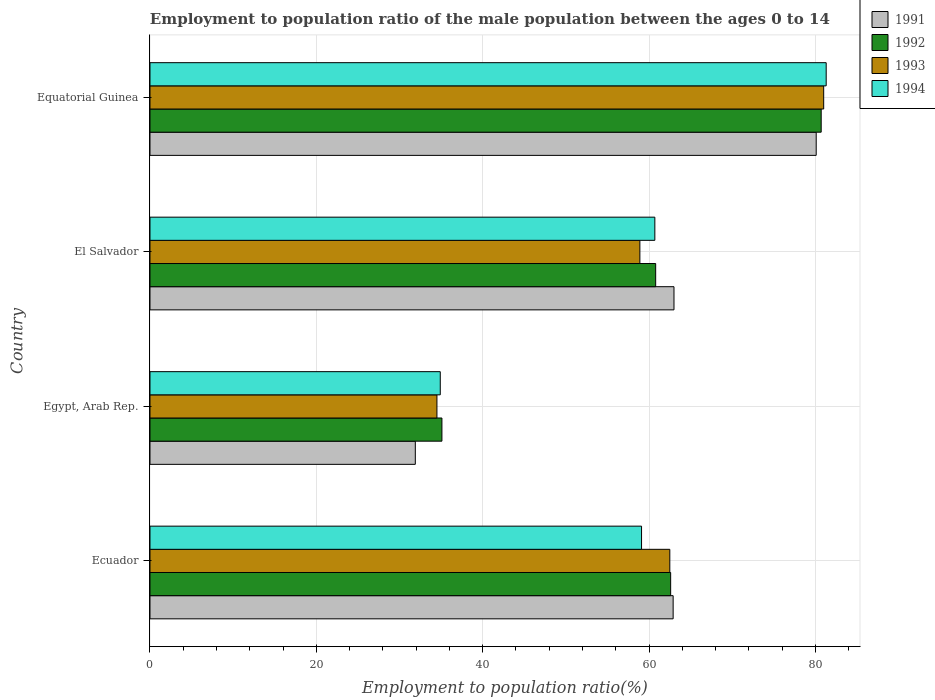How many groups of bars are there?
Your answer should be compact. 4. Are the number of bars on each tick of the Y-axis equal?
Provide a short and direct response. Yes. How many bars are there on the 2nd tick from the bottom?
Your answer should be very brief. 4. What is the label of the 4th group of bars from the top?
Provide a succinct answer. Ecuador. In how many cases, is the number of bars for a given country not equal to the number of legend labels?
Keep it short and to the point. 0. What is the employment to population ratio in 1992 in Equatorial Guinea?
Offer a terse response. 80.7. Across all countries, what is the minimum employment to population ratio in 1991?
Keep it short and to the point. 31.9. In which country was the employment to population ratio in 1993 maximum?
Your answer should be compact. Equatorial Guinea. In which country was the employment to population ratio in 1991 minimum?
Your answer should be very brief. Egypt, Arab Rep. What is the total employment to population ratio in 1992 in the graph?
Your answer should be very brief. 239.2. What is the difference between the employment to population ratio in 1992 in Ecuador and that in Egypt, Arab Rep.?
Provide a short and direct response. 27.5. What is the difference between the employment to population ratio in 1991 in Egypt, Arab Rep. and the employment to population ratio in 1992 in Ecuador?
Your response must be concise. -30.7. What is the average employment to population ratio in 1992 per country?
Provide a short and direct response. 59.8. What is the difference between the employment to population ratio in 1994 and employment to population ratio in 1992 in Egypt, Arab Rep.?
Keep it short and to the point. -0.2. In how many countries, is the employment to population ratio in 1993 greater than 68 %?
Keep it short and to the point. 1. What is the ratio of the employment to population ratio in 1993 in Egypt, Arab Rep. to that in Equatorial Guinea?
Ensure brevity in your answer.  0.43. What is the difference between the highest and the second highest employment to population ratio in 1992?
Your answer should be very brief. 18.1. What is the difference between the highest and the lowest employment to population ratio in 1993?
Your response must be concise. 46.5. Is the sum of the employment to population ratio in 1994 in Ecuador and El Salvador greater than the maximum employment to population ratio in 1991 across all countries?
Your answer should be compact. Yes. What does the 4th bar from the top in El Salvador represents?
Your answer should be compact. 1991. What does the 2nd bar from the bottom in Ecuador represents?
Your answer should be very brief. 1992. Are all the bars in the graph horizontal?
Give a very brief answer. Yes. Does the graph contain any zero values?
Offer a terse response. No. Where does the legend appear in the graph?
Your answer should be compact. Top right. How many legend labels are there?
Provide a short and direct response. 4. What is the title of the graph?
Provide a succinct answer. Employment to population ratio of the male population between the ages 0 to 14. What is the label or title of the X-axis?
Provide a succinct answer. Employment to population ratio(%). What is the Employment to population ratio(%) in 1991 in Ecuador?
Offer a terse response. 62.9. What is the Employment to population ratio(%) in 1992 in Ecuador?
Your answer should be compact. 62.6. What is the Employment to population ratio(%) in 1993 in Ecuador?
Offer a very short reply. 62.5. What is the Employment to population ratio(%) in 1994 in Ecuador?
Ensure brevity in your answer.  59.1. What is the Employment to population ratio(%) in 1991 in Egypt, Arab Rep.?
Your answer should be compact. 31.9. What is the Employment to population ratio(%) in 1992 in Egypt, Arab Rep.?
Provide a succinct answer. 35.1. What is the Employment to population ratio(%) in 1993 in Egypt, Arab Rep.?
Offer a very short reply. 34.5. What is the Employment to population ratio(%) in 1994 in Egypt, Arab Rep.?
Offer a very short reply. 34.9. What is the Employment to population ratio(%) in 1991 in El Salvador?
Provide a succinct answer. 63. What is the Employment to population ratio(%) of 1992 in El Salvador?
Your answer should be very brief. 60.8. What is the Employment to population ratio(%) of 1993 in El Salvador?
Provide a short and direct response. 58.9. What is the Employment to population ratio(%) of 1994 in El Salvador?
Make the answer very short. 60.7. What is the Employment to population ratio(%) in 1991 in Equatorial Guinea?
Offer a terse response. 80.1. What is the Employment to population ratio(%) of 1992 in Equatorial Guinea?
Your response must be concise. 80.7. What is the Employment to population ratio(%) of 1993 in Equatorial Guinea?
Provide a short and direct response. 81. What is the Employment to population ratio(%) in 1994 in Equatorial Guinea?
Your answer should be very brief. 81.3. Across all countries, what is the maximum Employment to population ratio(%) in 1991?
Provide a short and direct response. 80.1. Across all countries, what is the maximum Employment to population ratio(%) in 1992?
Offer a terse response. 80.7. Across all countries, what is the maximum Employment to population ratio(%) of 1993?
Your answer should be very brief. 81. Across all countries, what is the maximum Employment to population ratio(%) of 1994?
Provide a short and direct response. 81.3. Across all countries, what is the minimum Employment to population ratio(%) of 1991?
Your response must be concise. 31.9. Across all countries, what is the minimum Employment to population ratio(%) of 1992?
Make the answer very short. 35.1. Across all countries, what is the minimum Employment to population ratio(%) in 1993?
Your answer should be compact. 34.5. Across all countries, what is the minimum Employment to population ratio(%) of 1994?
Give a very brief answer. 34.9. What is the total Employment to population ratio(%) of 1991 in the graph?
Your answer should be very brief. 237.9. What is the total Employment to population ratio(%) of 1992 in the graph?
Keep it short and to the point. 239.2. What is the total Employment to population ratio(%) in 1993 in the graph?
Your answer should be very brief. 236.9. What is the total Employment to population ratio(%) in 1994 in the graph?
Offer a very short reply. 236. What is the difference between the Employment to population ratio(%) in 1992 in Ecuador and that in Egypt, Arab Rep.?
Offer a very short reply. 27.5. What is the difference between the Employment to population ratio(%) in 1993 in Ecuador and that in Egypt, Arab Rep.?
Make the answer very short. 28. What is the difference between the Employment to population ratio(%) in 1994 in Ecuador and that in Egypt, Arab Rep.?
Your answer should be compact. 24.2. What is the difference between the Employment to population ratio(%) of 1991 in Ecuador and that in El Salvador?
Your response must be concise. -0.1. What is the difference between the Employment to population ratio(%) in 1992 in Ecuador and that in El Salvador?
Give a very brief answer. 1.8. What is the difference between the Employment to population ratio(%) of 1994 in Ecuador and that in El Salvador?
Your answer should be very brief. -1.6. What is the difference between the Employment to population ratio(%) in 1991 in Ecuador and that in Equatorial Guinea?
Offer a terse response. -17.2. What is the difference between the Employment to population ratio(%) in 1992 in Ecuador and that in Equatorial Guinea?
Give a very brief answer. -18.1. What is the difference between the Employment to population ratio(%) in 1993 in Ecuador and that in Equatorial Guinea?
Give a very brief answer. -18.5. What is the difference between the Employment to population ratio(%) in 1994 in Ecuador and that in Equatorial Guinea?
Ensure brevity in your answer.  -22.2. What is the difference between the Employment to population ratio(%) of 1991 in Egypt, Arab Rep. and that in El Salvador?
Keep it short and to the point. -31.1. What is the difference between the Employment to population ratio(%) in 1992 in Egypt, Arab Rep. and that in El Salvador?
Offer a very short reply. -25.7. What is the difference between the Employment to population ratio(%) of 1993 in Egypt, Arab Rep. and that in El Salvador?
Your response must be concise. -24.4. What is the difference between the Employment to population ratio(%) in 1994 in Egypt, Arab Rep. and that in El Salvador?
Keep it short and to the point. -25.8. What is the difference between the Employment to population ratio(%) of 1991 in Egypt, Arab Rep. and that in Equatorial Guinea?
Ensure brevity in your answer.  -48.2. What is the difference between the Employment to population ratio(%) in 1992 in Egypt, Arab Rep. and that in Equatorial Guinea?
Make the answer very short. -45.6. What is the difference between the Employment to population ratio(%) of 1993 in Egypt, Arab Rep. and that in Equatorial Guinea?
Give a very brief answer. -46.5. What is the difference between the Employment to population ratio(%) in 1994 in Egypt, Arab Rep. and that in Equatorial Guinea?
Make the answer very short. -46.4. What is the difference between the Employment to population ratio(%) in 1991 in El Salvador and that in Equatorial Guinea?
Your answer should be very brief. -17.1. What is the difference between the Employment to population ratio(%) of 1992 in El Salvador and that in Equatorial Guinea?
Ensure brevity in your answer.  -19.9. What is the difference between the Employment to population ratio(%) in 1993 in El Salvador and that in Equatorial Guinea?
Ensure brevity in your answer.  -22.1. What is the difference between the Employment to population ratio(%) in 1994 in El Salvador and that in Equatorial Guinea?
Your response must be concise. -20.6. What is the difference between the Employment to population ratio(%) in 1991 in Ecuador and the Employment to population ratio(%) in 1992 in Egypt, Arab Rep.?
Give a very brief answer. 27.8. What is the difference between the Employment to population ratio(%) of 1991 in Ecuador and the Employment to population ratio(%) of 1993 in Egypt, Arab Rep.?
Your answer should be compact. 28.4. What is the difference between the Employment to population ratio(%) in 1992 in Ecuador and the Employment to population ratio(%) in 1993 in Egypt, Arab Rep.?
Your answer should be compact. 28.1. What is the difference between the Employment to population ratio(%) of 1992 in Ecuador and the Employment to population ratio(%) of 1994 in Egypt, Arab Rep.?
Offer a terse response. 27.7. What is the difference between the Employment to population ratio(%) in 1993 in Ecuador and the Employment to population ratio(%) in 1994 in Egypt, Arab Rep.?
Provide a short and direct response. 27.6. What is the difference between the Employment to population ratio(%) in 1992 in Ecuador and the Employment to population ratio(%) in 1993 in El Salvador?
Offer a terse response. 3.7. What is the difference between the Employment to population ratio(%) in 1992 in Ecuador and the Employment to population ratio(%) in 1994 in El Salvador?
Your answer should be compact. 1.9. What is the difference between the Employment to population ratio(%) of 1991 in Ecuador and the Employment to population ratio(%) of 1992 in Equatorial Guinea?
Offer a very short reply. -17.8. What is the difference between the Employment to population ratio(%) in 1991 in Ecuador and the Employment to population ratio(%) in 1993 in Equatorial Guinea?
Your answer should be very brief. -18.1. What is the difference between the Employment to population ratio(%) in 1991 in Ecuador and the Employment to population ratio(%) in 1994 in Equatorial Guinea?
Make the answer very short. -18.4. What is the difference between the Employment to population ratio(%) of 1992 in Ecuador and the Employment to population ratio(%) of 1993 in Equatorial Guinea?
Your answer should be very brief. -18.4. What is the difference between the Employment to population ratio(%) of 1992 in Ecuador and the Employment to population ratio(%) of 1994 in Equatorial Guinea?
Offer a terse response. -18.7. What is the difference between the Employment to population ratio(%) of 1993 in Ecuador and the Employment to population ratio(%) of 1994 in Equatorial Guinea?
Your answer should be compact. -18.8. What is the difference between the Employment to population ratio(%) in 1991 in Egypt, Arab Rep. and the Employment to population ratio(%) in 1992 in El Salvador?
Ensure brevity in your answer.  -28.9. What is the difference between the Employment to population ratio(%) in 1991 in Egypt, Arab Rep. and the Employment to population ratio(%) in 1993 in El Salvador?
Your response must be concise. -27. What is the difference between the Employment to population ratio(%) of 1991 in Egypt, Arab Rep. and the Employment to population ratio(%) of 1994 in El Salvador?
Your answer should be very brief. -28.8. What is the difference between the Employment to population ratio(%) in 1992 in Egypt, Arab Rep. and the Employment to population ratio(%) in 1993 in El Salvador?
Ensure brevity in your answer.  -23.8. What is the difference between the Employment to population ratio(%) in 1992 in Egypt, Arab Rep. and the Employment to population ratio(%) in 1994 in El Salvador?
Offer a terse response. -25.6. What is the difference between the Employment to population ratio(%) in 1993 in Egypt, Arab Rep. and the Employment to population ratio(%) in 1994 in El Salvador?
Your answer should be very brief. -26.2. What is the difference between the Employment to population ratio(%) in 1991 in Egypt, Arab Rep. and the Employment to population ratio(%) in 1992 in Equatorial Guinea?
Offer a very short reply. -48.8. What is the difference between the Employment to population ratio(%) of 1991 in Egypt, Arab Rep. and the Employment to population ratio(%) of 1993 in Equatorial Guinea?
Your response must be concise. -49.1. What is the difference between the Employment to population ratio(%) in 1991 in Egypt, Arab Rep. and the Employment to population ratio(%) in 1994 in Equatorial Guinea?
Your response must be concise. -49.4. What is the difference between the Employment to population ratio(%) in 1992 in Egypt, Arab Rep. and the Employment to population ratio(%) in 1993 in Equatorial Guinea?
Offer a terse response. -45.9. What is the difference between the Employment to population ratio(%) of 1992 in Egypt, Arab Rep. and the Employment to population ratio(%) of 1994 in Equatorial Guinea?
Your answer should be very brief. -46.2. What is the difference between the Employment to population ratio(%) in 1993 in Egypt, Arab Rep. and the Employment to population ratio(%) in 1994 in Equatorial Guinea?
Your response must be concise. -46.8. What is the difference between the Employment to population ratio(%) in 1991 in El Salvador and the Employment to population ratio(%) in 1992 in Equatorial Guinea?
Your answer should be very brief. -17.7. What is the difference between the Employment to population ratio(%) of 1991 in El Salvador and the Employment to population ratio(%) of 1993 in Equatorial Guinea?
Your answer should be very brief. -18. What is the difference between the Employment to population ratio(%) of 1991 in El Salvador and the Employment to population ratio(%) of 1994 in Equatorial Guinea?
Offer a very short reply. -18.3. What is the difference between the Employment to population ratio(%) in 1992 in El Salvador and the Employment to population ratio(%) in 1993 in Equatorial Guinea?
Keep it short and to the point. -20.2. What is the difference between the Employment to population ratio(%) of 1992 in El Salvador and the Employment to population ratio(%) of 1994 in Equatorial Guinea?
Keep it short and to the point. -20.5. What is the difference between the Employment to population ratio(%) in 1993 in El Salvador and the Employment to population ratio(%) in 1994 in Equatorial Guinea?
Make the answer very short. -22.4. What is the average Employment to population ratio(%) of 1991 per country?
Provide a short and direct response. 59.48. What is the average Employment to population ratio(%) of 1992 per country?
Provide a succinct answer. 59.8. What is the average Employment to population ratio(%) in 1993 per country?
Give a very brief answer. 59.23. What is the difference between the Employment to population ratio(%) in 1991 and Employment to population ratio(%) in 1993 in Ecuador?
Provide a short and direct response. 0.4. What is the difference between the Employment to population ratio(%) of 1991 and Employment to population ratio(%) of 1994 in Ecuador?
Offer a terse response. 3.8. What is the difference between the Employment to population ratio(%) in 1992 and Employment to population ratio(%) in 1993 in Ecuador?
Your response must be concise. 0.1. What is the difference between the Employment to population ratio(%) of 1992 and Employment to population ratio(%) of 1994 in Ecuador?
Provide a short and direct response. 3.5. What is the difference between the Employment to population ratio(%) of 1993 and Employment to population ratio(%) of 1994 in Ecuador?
Provide a succinct answer. 3.4. What is the difference between the Employment to population ratio(%) in 1991 and Employment to population ratio(%) in 1994 in Egypt, Arab Rep.?
Your answer should be very brief. -3. What is the difference between the Employment to population ratio(%) in 1992 and Employment to population ratio(%) in 1993 in Egypt, Arab Rep.?
Provide a succinct answer. 0.6. What is the difference between the Employment to population ratio(%) in 1993 and Employment to population ratio(%) in 1994 in Egypt, Arab Rep.?
Provide a succinct answer. -0.4. What is the difference between the Employment to population ratio(%) of 1991 and Employment to population ratio(%) of 1992 in El Salvador?
Keep it short and to the point. 2.2. What is the difference between the Employment to population ratio(%) of 1991 and Employment to population ratio(%) of 1993 in El Salvador?
Provide a succinct answer. 4.1. What is the difference between the Employment to population ratio(%) in 1992 and Employment to population ratio(%) in 1993 in El Salvador?
Your answer should be compact. 1.9. What is the difference between the Employment to population ratio(%) of 1991 and Employment to population ratio(%) of 1994 in Equatorial Guinea?
Your answer should be compact. -1.2. What is the difference between the Employment to population ratio(%) in 1992 and Employment to population ratio(%) in 1993 in Equatorial Guinea?
Offer a terse response. -0.3. What is the difference between the Employment to population ratio(%) of 1993 and Employment to population ratio(%) of 1994 in Equatorial Guinea?
Provide a succinct answer. -0.3. What is the ratio of the Employment to population ratio(%) of 1991 in Ecuador to that in Egypt, Arab Rep.?
Your answer should be compact. 1.97. What is the ratio of the Employment to population ratio(%) in 1992 in Ecuador to that in Egypt, Arab Rep.?
Keep it short and to the point. 1.78. What is the ratio of the Employment to population ratio(%) in 1993 in Ecuador to that in Egypt, Arab Rep.?
Your response must be concise. 1.81. What is the ratio of the Employment to population ratio(%) in 1994 in Ecuador to that in Egypt, Arab Rep.?
Provide a succinct answer. 1.69. What is the ratio of the Employment to population ratio(%) in 1992 in Ecuador to that in El Salvador?
Your answer should be compact. 1.03. What is the ratio of the Employment to population ratio(%) in 1993 in Ecuador to that in El Salvador?
Keep it short and to the point. 1.06. What is the ratio of the Employment to population ratio(%) in 1994 in Ecuador to that in El Salvador?
Your answer should be compact. 0.97. What is the ratio of the Employment to population ratio(%) of 1991 in Ecuador to that in Equatorial Guinea?
Offer a terse response. 0.79. What is the ratio of the Employment to population ratio(%) in 1992 in Ecuador to that in Equatorial Guinea?
Keep it short and to the point. 0.78. What is the ratio of the Employment to population ratio(%) in 1993 in Ecuador to that in Equatorial Guinea?
Provide a short and direct response. 0.77. What is the ratio of the Employment to population ratio(%) of 1994 in Ecuador to that in Equatorial Guinea?
Provide a succinct answer. 0.73. What is the ratio of the Employment to population ratio(%) of 1991 in Egypt, Arab Rep. to that in El Salvador?
Give a very brief answer. 0.51. What is the ratio of the Employment to population ratio(%) of 1992 in Egypt, Arab Rep. to that in El Salvador?
Ensure brevity in your answer.  0.58. What is the ratio of the Employment to population ratio(%) in 1993 in Egypt, Arab Rep. to that in El Salvador?
Your answer should be compact. 0.59. What is the ratio of the Employment to population ratio(%) of 1994 in Egypt, Arab Rep. to that in El Salvador?
Your answer should be compact. 0.57. What is the ratio of the Employment to population ratio(%) in 1991 in Egypt, Arab Rep. to that in Equatorial Guinea?
Offer a very short reply. 0.4. What is the ratio of the Employment to population ratio(%) of 1992 in Egypt, Arab Rep. to that in Equatorial Guinea?
Your response must be concise. 0.43. What is the ratio of the Employment to population ratio(%) of 1993 in Egypt, Arab Rep. to that in Equatorial Guinea?
Provide a short and direct response. 0.43. What is the ratio of the Employment to population ratio(%) in 1994 in Egypt, Arab Rep. to that in Equatorial Guinea?
Your answer should be very brief. 0.43. What is the ratio of the Employment to population ratio(%) in 1991 in El Salvador to that in Equatorial Guinea?
Make the answer very short. 0.79. What is the ratio of the Employment to population ratio(%) of 1992 in El Salvador to that in Equatorial Guinea?
Offer a very short reply. 0.75. What is the ratio of the Employment to population ratio(%) in 1993 in El Salvador to that in Equatorial Guinea?
Your response must be concise. 0.73. What is the ratio of the Employment to population ratio(%) in 1994 in El Salvador to that in Equatorial Guinea?
Keep it short and to the point. 0.75. What is the difference between the highest and the second highest Employment to population ratio(%) of 1993?
Make the answer very short. 18.5. What is the difference between the highest and the second highest Employment to population ratio(%) of 1994?
Make the answer very short. 20.6. What is the difference between the highest and the lowest Employment to population ratio(%) of 1991?
Give a very brief answer. 48.2. What is the difference between the highest and the lowest Employment to population ratio(%) of 1992?
Make the answer very short. 45.6. What is the difference between the highest and the lowest Employment to population ratio(%) of 1993?
Keep it short and to the point. 46.5. What is the difference between the highest and the lowest Employment to population ratio(%) in 1994?
Your response must be concise. 46.4. 